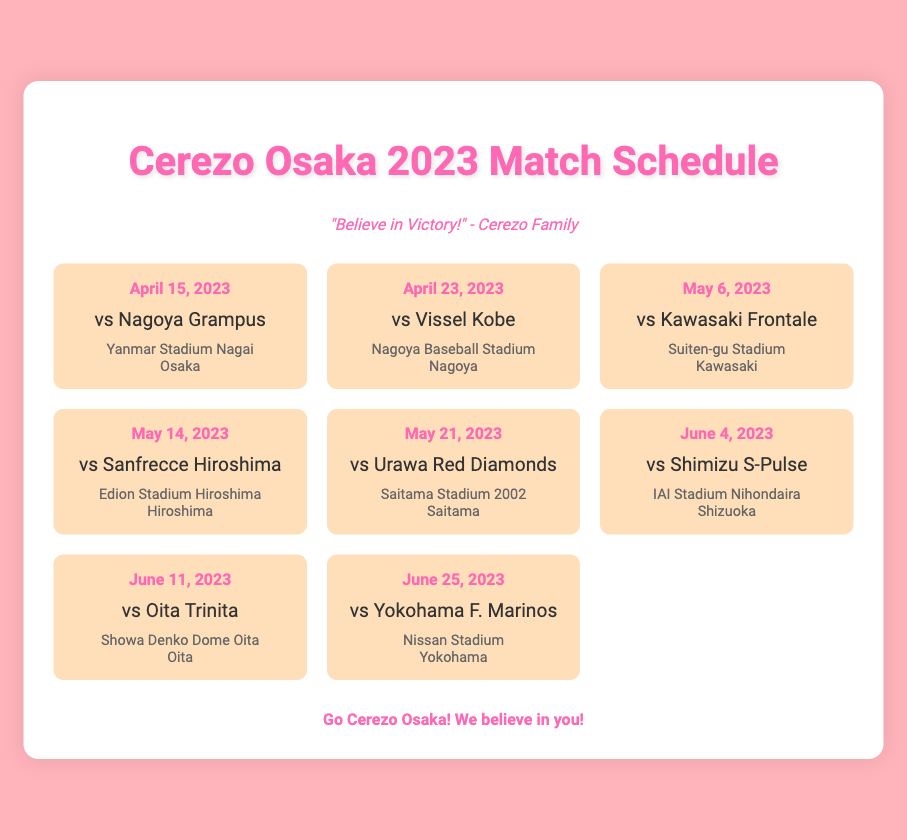What is the date of the match against Nagoya Grampus? The match against Nagoya Grampus is scheduled for April 15, 2023.
Answer: April 15, 2023 What stadium will host the match on May 21, 2023? The match on May 21, 2023, will be hosted at Saitama Stadium 2002.
Answer: Saitama Stadium 2002 Who is the opponent for the match on June 25, 2023? The opponent for the match on June 25, 2023, is Yokohama F. Marinos.
Answer: Yokohama F. Marinos What is the location of the match on June 11, 2023? The match on June 11, 2023, is located in Oita.
Answer: Oita How many matches are scheduled in June 2023? There are three matches scheduled in June 2023: June 4, June 11, and June 25.
Answer: Three Which team will Cerezo Osaka play against at IAI Stadium Nihondaira? Cerezo Osaka will play against Shimizu S-Pulse at IAI Stadium Nihondaira.
Answer: Shimizu S-Pulse What color is the Cerezo Osaka team color mentioned in the document? The color associated with Cerezo Osaka in the document is pink.
Answer: Pink What is the phrase displayed in the team info section? The phrase displayed in the team info section is "Believe in Victory!"
Answer: Believe in Victory! 